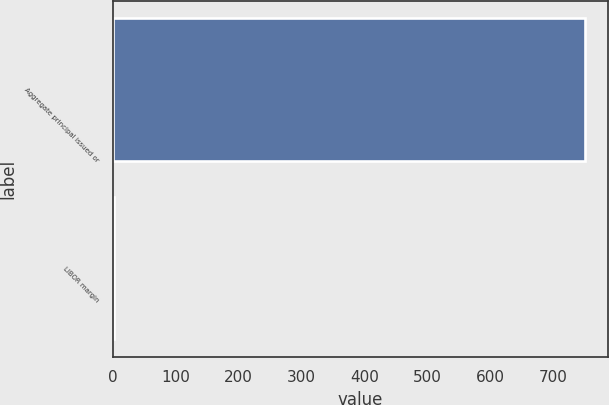Convert chart to OTSL. <chart><loc_0><loc_0><loc_500><loc_500><bar_chart><fcel>Aggregate principal issued or<fcel>LIBOR margin<nl><fcel>750<fcel>2<nl></chart> 